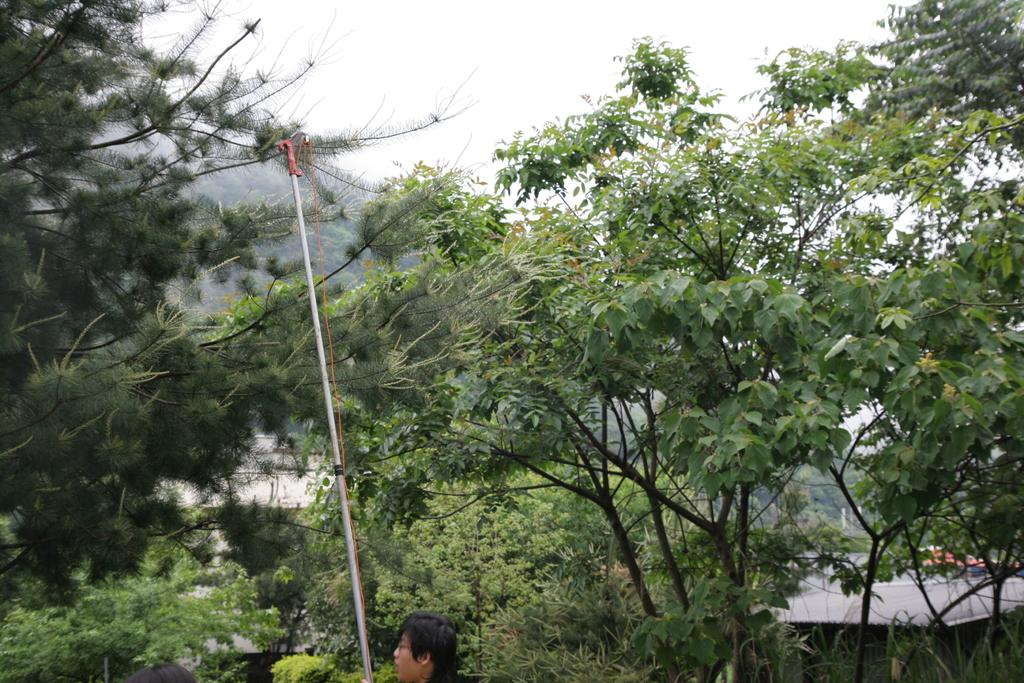Who is present in the image? There is a man in the image. What is the man holding in the image? The man is holding a stick. What can be seen in the background of the image? There are trees in the background of the image. What territory is the governor trying to smash in the image? There is no governor or territory present in the image; it only features a man holding a stick and trees in the background. 